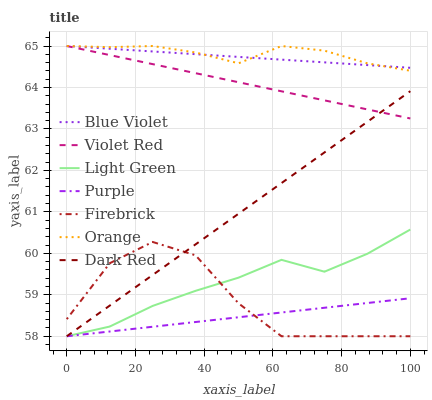Does Purple have the minimum area under the curve?
Answer yes or no. Yes. Does Dark Red have the minimum area under the curve?
Answer yes or no. No. Does Dark Red have the maximum area under the curve?
Answer yes or no. No. Is Violet Red the smoothest?
Answer yes or no. Yes. Is Firebrick the roughest?
Answer yes or no. Yes. Is Purple the smoothest?
Answer yes or no. No. Is Purple the roughest?
Answer yes or no. No. Does Orange have the lowest value?
Answer yes or no. No. Does Dark Red have the highest value?
Answer yes or no. No. Is Dark Red less than Orange?
Answer yes or no. Yes. Is Blue Violet greater than Light Green?
Answer yes or no. Yes. Does Dark Red intersect Orange?
Answer yes or no. No. 